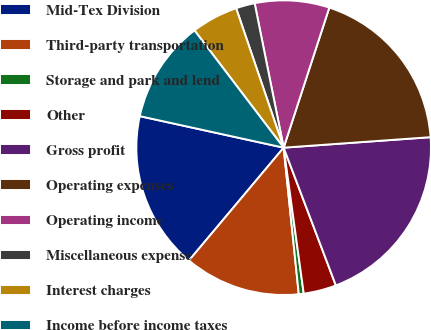Convert chart. <chart><loc_0><loc_0><loc_500><loc_500><pie_chart><fcel>Mid-Tex Division<fcel>Third-party transportation<fcel>Storage and park and lend<fcel>Other<fcel>Gross profit<fcel>Operating expenses<fcel>Operating income<fcel>Miscellaneous expense<fcel>Interest charges<fcel>Income before income taxes<nl><fcel>17.32%<fcel>12.75%<fcel>0.54%<fcel>3.59%<fcel>20.37%<fcel>18.85%<fcel>8.17%<fcel>2.07%<fcel>5.12%<fcel>11.22%<nl></chart> 